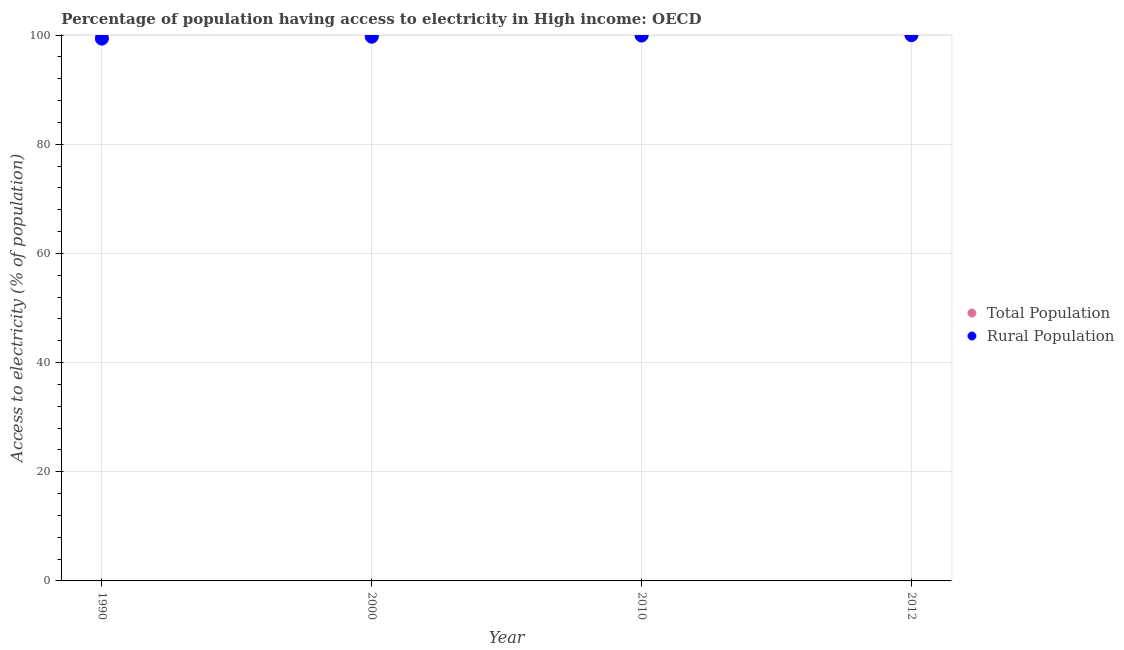Is the number of dotlines equal to the number of legend labels?
Your response must be concise. Yes. What is the percentage of rural population having access to electricity in 2010?
Offer a terse response. 99.9. Across all years, what is the maximum percentage of population having access to electricity?
Give a very brief answer. 99.99. Across all years, what is the minimum percentage of population having access to electricity?
Your answer should be very brief. 99.64. In which year was the percentage of population having access to electricity maximum?
Your answer should be compact. 2012. What is the total percentage of population having access to electricity in the graph?
Make the answer very short. 399.49. What is the difference between the percentage of population having access to electricity in 2000 and that in 2010?
Provide a short and direct response. -0.08. What is the difference between the percentage of rural population having access to electricity in 2010 and the percentage of population having access to electricity in 2012?
Provide a succinct answer. -0.1. What is the average percentage of population having access to electricity per year?
Offer a terse response. 99.87. In the year 2000, what is the difference between the percentage of population having access to electricity and percentage of rural population having access to electricity?
Your answer should be very brief. 0.2. What is the ratio of the percentage of population having access to electricity in 2010 to that in 2012?
Offer a terse response. 1. Is the difference between the percentage of population having access to electricity in 1990 and 2012 greater than the difference between the percentage of rural population having access to electricity in 1990 and 2012?
Your response must be concise. Yes. What is the difference between the highest and the second highest percentage of rural population having access to electricity?
Offer a terse response. 0.08. What is the difference between the highest and the lowest percentage of rural population having access to electricity?
Provide a short and direct response. 0.64. In how many years, is the percentage of rural population having access to electricity greater than the average percentage of rural population having access to electricity taken over all years?
Your answer should be very brief. 2. Is the sum of the percentage of population having access to electricity in 1990 and 2010 greater than the maximum percentage of rural population having access to electricity across all years?
Your answer should be very brief. Yes. Does the percentage of rural population having access to electricity monotonically increase over the years?
Provide a short and direct response. Yes. What is the title of the graph?
Make the answer very short. Percentage of population having access to electricity in High income: OECD. What is the label or title of the X-axis?
Provide a short and direct response. Year. What is the label or title of the Y-axis?
Provide a succinct answer. Access to electricity (% of population). What is the Access to electricity (% of population) of Total Population in 1990?
Your answer should be compact. 99.64. What is the Access to electricity (% of population) in Rural Population in 1990?
Your answer should be very brief. 99.34. What is the Access to electricity (% of population) in Total Population in 2000?
Provide a short and direct response. 99.89. What is the Access to electricity (% of population) in Rural Population in 2000?
Provide a short and direct response. 99.68. What is the Access to electricity (% of population) of Total Population in 2010?
Offer a terse response. 99.97. What is the Access to electricity (% of population) of Rural Population in 2010?
Provide a succinct answer. 99.9. What is the Access to electricity (% of population) of Total Population in 2012?
Ensure brevity in your answer.  99.99. What is the Access to electricity (% of population) in Rural Population in 2012?
Make the answer very short. 99.98. Across all years, what is the maximum Access to electricity (% of population) in Total Population?
Your answer should be very brief. 99.99. Across all years, what is the maximum Access to electricity (% of population) in Rural Population?
Your answer should be very brief. 99.98. Across all years, what is the minimum Access to electricity (% of population) in Total Population?
Offer a very short reply. 99.64. Across all years, what is the minimum Access to electricity (% of population) in Rural Population?
Keep it short and to the point. 99.34. What is the total Access to electricity (% of population) in Total Population in the graph?
Keep it short and to the point. 399.49. What is the total Access to electricity (% of population) of Rural Population in the graph?
Your response must be concise. 398.9. What is the difference between the Access to electricity (% of population) in Total Population in 1990 and that in 2000?
Your answer should be compact. -0.24. What is the difference between the Access to electricity (% of population) of Rural Population in 1990 and that in 2000?
Your answer should be very brief. -0.34. What is the difference between the Access to electricity (% of population) in Total Population in 1990 and that in 2010?
Ensure brevity in your answer.  -0.33. What is the difference between the Access to electricity (% of population) of Rural Population in 1990 and that in 2010?
Provide a succinct answer. -0.55. What is the difference between the Access to electricity (% of population) in Total Population in 1990 and that in 2012?
Keep it short and to the point. -0.35. What is the difference between the Access to electricity (% of population) in Rural Population in 1990 and that in 2012?
Provide a short and direct response. -0.64. What is the difference between the Access to electricity (% of population) in Total Population in 2000 and that in 2010?
Give a very brief answer. -0.08. What is the difference between the Access to electricity (% of population) of Rural Population in 2000 and that in 2010?
Provide a short and direct response. -0.21. What is the difference between the Access to electricity (% of population) in Total Population in 2000 and that in 2012?
Offer a terse response. -0.11. What is the difference between the Access to electricity (% of population) of Rural Population in 2000 and that in 2012?
Your response must be concise. -0.3. What is the difference between the Access to electricity (% of population) of Total Population in 2010 and that in 2012?
Your answer should be very brief. -0.02. What is the difference between the Access to electricity (% of population) in Rural Population in 2010 and that in 2012?
Your answer should be very brief. -0.08. What is the difference between the Access to electricity (% of population) of Total Population in 1990 and the Access to electricity (% of population) of Rural Population in 2000?
Make the answer very short. -0.04. What is the difference between the Access to electricity (% of population) in Total Population in 1990 and the Access to electricity (% of population) in Rural Population in 2010?
Offer a terse response. -0.25. What is the difference between the Access to electricity (% of population) in Total Population in 1990 and the Access to electricity (% of population) in Rural Population in 2012?
Your answer should be compact. -0.34. What is the difference between the Access to electricity (% of population) in Total Population in 2000 and the Access to electricity (% of population) in Rural Population in 2010?
Give a very brief answer. -0.01. What is the difference between the Access to electricity (% of population) in Total Population in 2000 and the Access to electricity (% of population) in Rural Population in 2012?
Give a very brief answer. -0.09. What is the difference between the Access to electricity (% of population) in Total Population in 2010 and the Access to electricity (% of population) in Rural Population in 2012?
Provide a succinct answer. -0.01. What is the average Access to electricity (% of population) in Total Population per year?
Provide a succinct answer. 99.87. What is the average Access to electricity (% of population) in Rural Population per year?
Your response must be concise. 99.73. In the year 1990, what is the difference between the Access to electricity (% of population) of Total Population and Access to electricity (% of population) of Rural Population?
Provide a short and direct response. 0.3. In the year 2000, what is the difference between the Access to electricity (% of population) in Total Population and Access to electricity (% of population) in Rural Population?
Offer a very short reply. 0.2. In the year 2010, what is the difference between the Access to electricity (% of population) in Total Population and Access to electricity (% of population) in Rural Population?
Provide a succinct answer. 0.07. In the year 2012, what is the difference between the Access to electricity (% of population) of Total Population and Access to electricity (% of population) of Rural Population?
Ensure brevity in your answer.  0.01. What is the ratio of the Access to electricity (% of population) of Total Population in 1990 to that in 2000?
Offer a terse response. 1. What is the ratio of the Access to electricity (% of population) of Total Population in 1990 to that in 2010?
Offer a very short reply. 1. What is the ratio of the Access to electricity (% of population) of Rural Population in 2000 to that in 2010?
Your answer should be very brief. 1. What is the ratio of the Access to electricity (% of population) in Total Population in 2000 to that in 2012?
Offer a terse response. 1. What is the ratio of the Access to electricity (% of population) in Rural Population in 2000 to that in 2012?
Your answer should be very brief. 1. What is the ratio of the Access to electricity (% of population) of Rural Population in 2010 to that in 2012?
Your answer should be compact. 1. What is the difference between the highest and the second highest Access to electricity (% of population) in Total Population?
Give a very brief answer. 0.02. What is the difference between the highest and the second highest Access to electricity (% of population) in Rural Population?
Your answer should be very brief. 0.08. What is the difference between the highest and the lowest Access to electricity (% of population) in Total Population?
Your response must be concise. 0.35. What is the difference between the highest and the lowest Access to electricity (% of population) of Rural Population?
Provide a short and direct response. 0.64. 